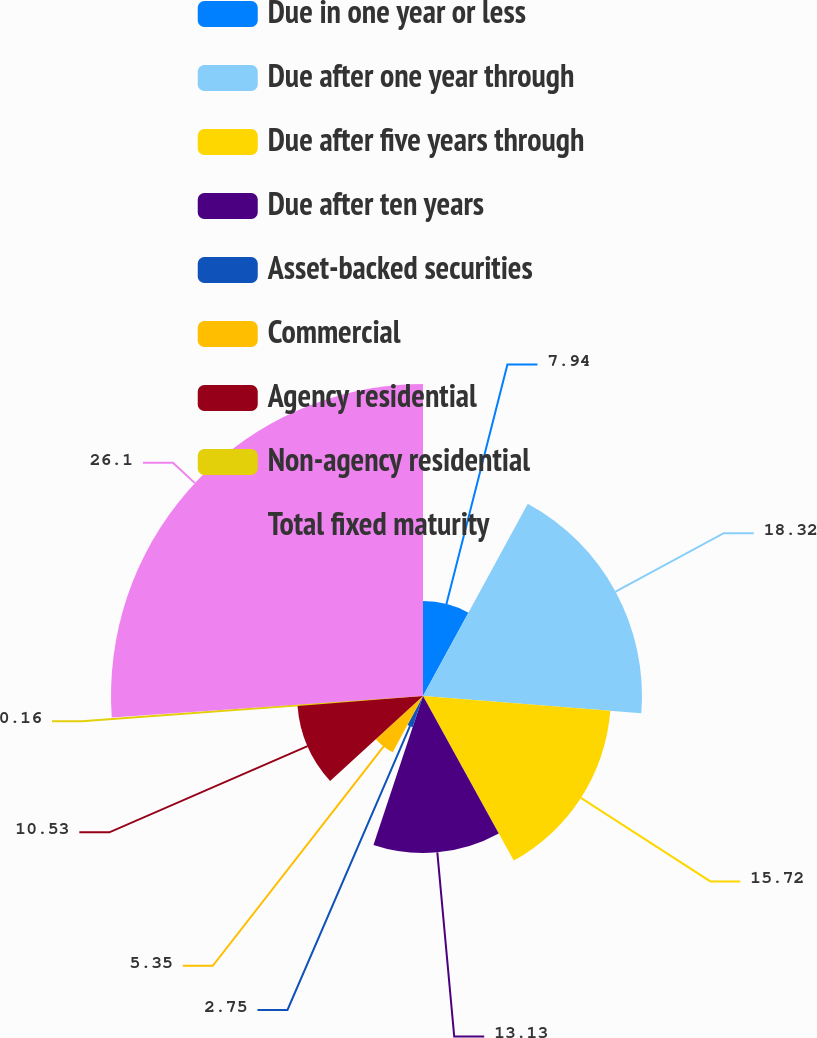Convert chart to OTSL. <chart><loc_0><loc_0><loc_500><loc_500><pie_chart><fcel>Due in one year or less<fcel>Due after one year through<fcel>Due after five years through<fcel>Due after ten years<fcel>Asset-backed securities<fcel>Commercial<fcel>Agency residential<fcel>Non-agency residential<fcel>Total fixed maturity<nl><fcel>7.94%<fcel>18.32%<fcel>15.72%<fcel>13.13%<fcel>2.75%<fcel>5.35%<fcel>10.53%<fcel>0.16%<fcel>26.1%<nl></chart> 